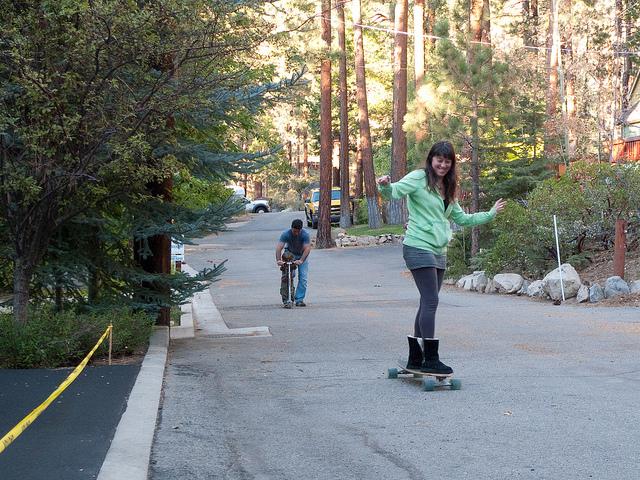What is the woman riding?
Concise answer only. Skateboard. Does the girl look happy?
Keep it brief. Yes. How many people are shown?
Be succinct. 2. 